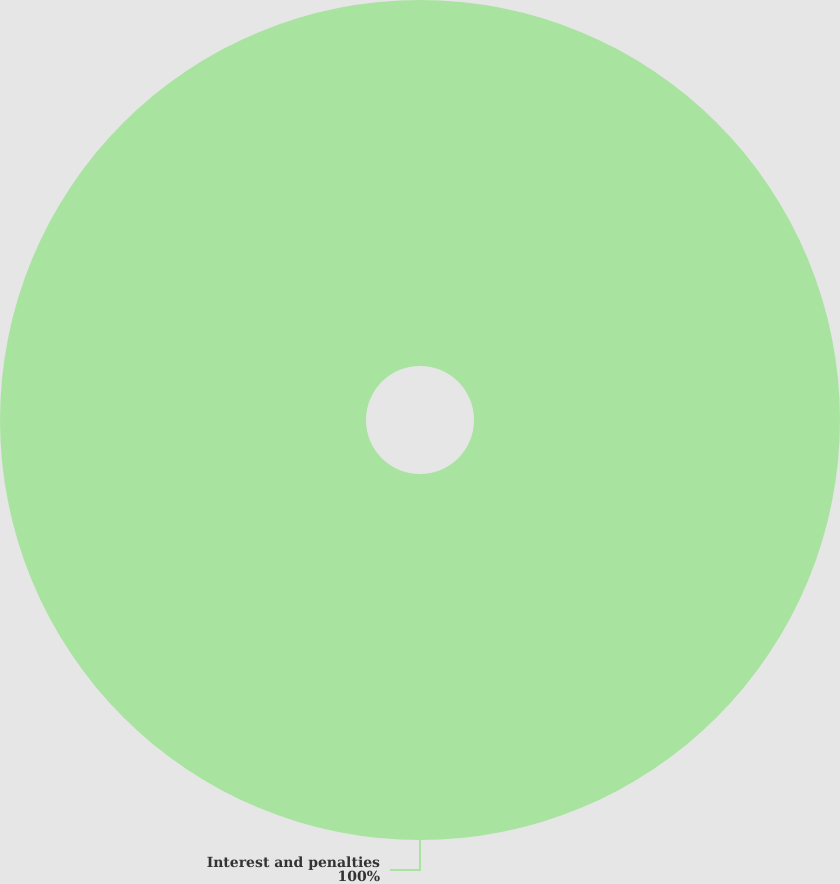<chart> <loc_0><loc_0><loc_500><loc_500><pie_chart><fcel>Interest and penalties<nl><fcel>100.0%<nl></chart> 